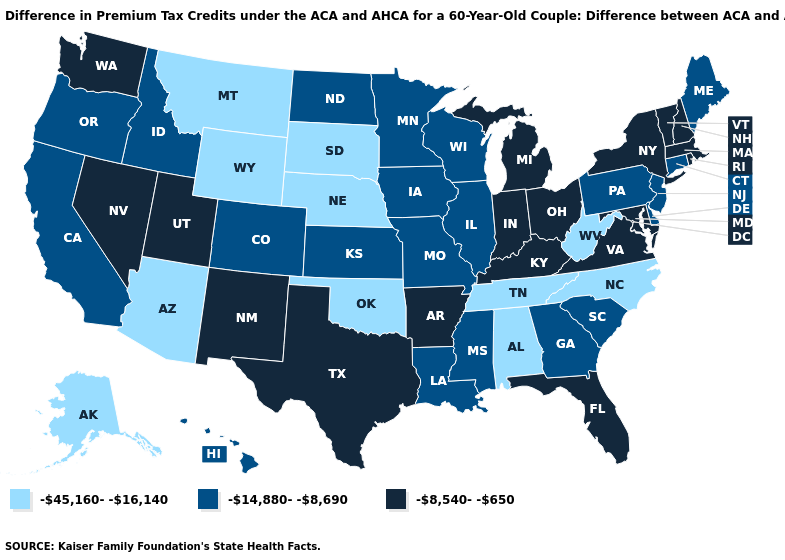Name the states that have a value in the range -45,160--16,140?
Be succinct. Alabama, Alaska, Arizona, Montana, Nebraska, North Carolina, Oklahoma, South Dakota, Tennessee, West Virginia, Wyoming. Name the states that have a value in the range -45,160--16,140?
Concise answer only. Alabama, Alaska, Arizona, Montana, Nebraska, North Carolina, Oklahoma, South Dakota, Tennessee, West Virginia, Wyoming. Name the states that have a value in the range -45,160--16,140?
Be succinct. Alabama, Alaska, Arizona, Montana, Nebraska, North Carolina, Oklahoma, South Dakota, Tennessee, West Virginia, Wyoming. Does the map have missing data?
Be succinct. No. Name the states that have a value in the range -45,160--16,140?
Keep it brief. Alabama, Alaska, Arizona, Montana, Nebraska, North Carolina, Oklahoma, South Dakota, Tennessee, West Virginia, Wyoming. Is the legend a continuous bar?
Short answer required. No. Among the states that border Maryland , which have the lowest value?
Answer briefly. West Virginia. What is the value of Pennsylvania?
Give a very brief answer. -14,880--8,690. Does the map have missing data?
Short answer required. No. Name the states that have a value in the range -45,160--16,140?
Keep it brief. Alabama, Alaska, Arizona, Montana, Nebraska, North Carolina, Oklahoma, South Dakota, Tennessee, West Virginia, Wyoming. What is the highest value in the Northeast ?
Keep it brief. -8,540--650. What is the value of Florida?
Give a very brief answer. -8,540--650. Is the legend a continuous bar?
Answer briefly. No. What is the highest value in the USA?
Give a very brief answer. -8,540--650. Name the states that have a value in the range -8,540--650?
Give a very brief answer. Arkansas, Florida, Indiana, Kentucky, Maryland, Massachusetts, Michigan, Nevada, New Hampshire, New Mexico, New York, Ohio, Rhode Island, Texas, Utah, Vermont, Virginia, Washington. 